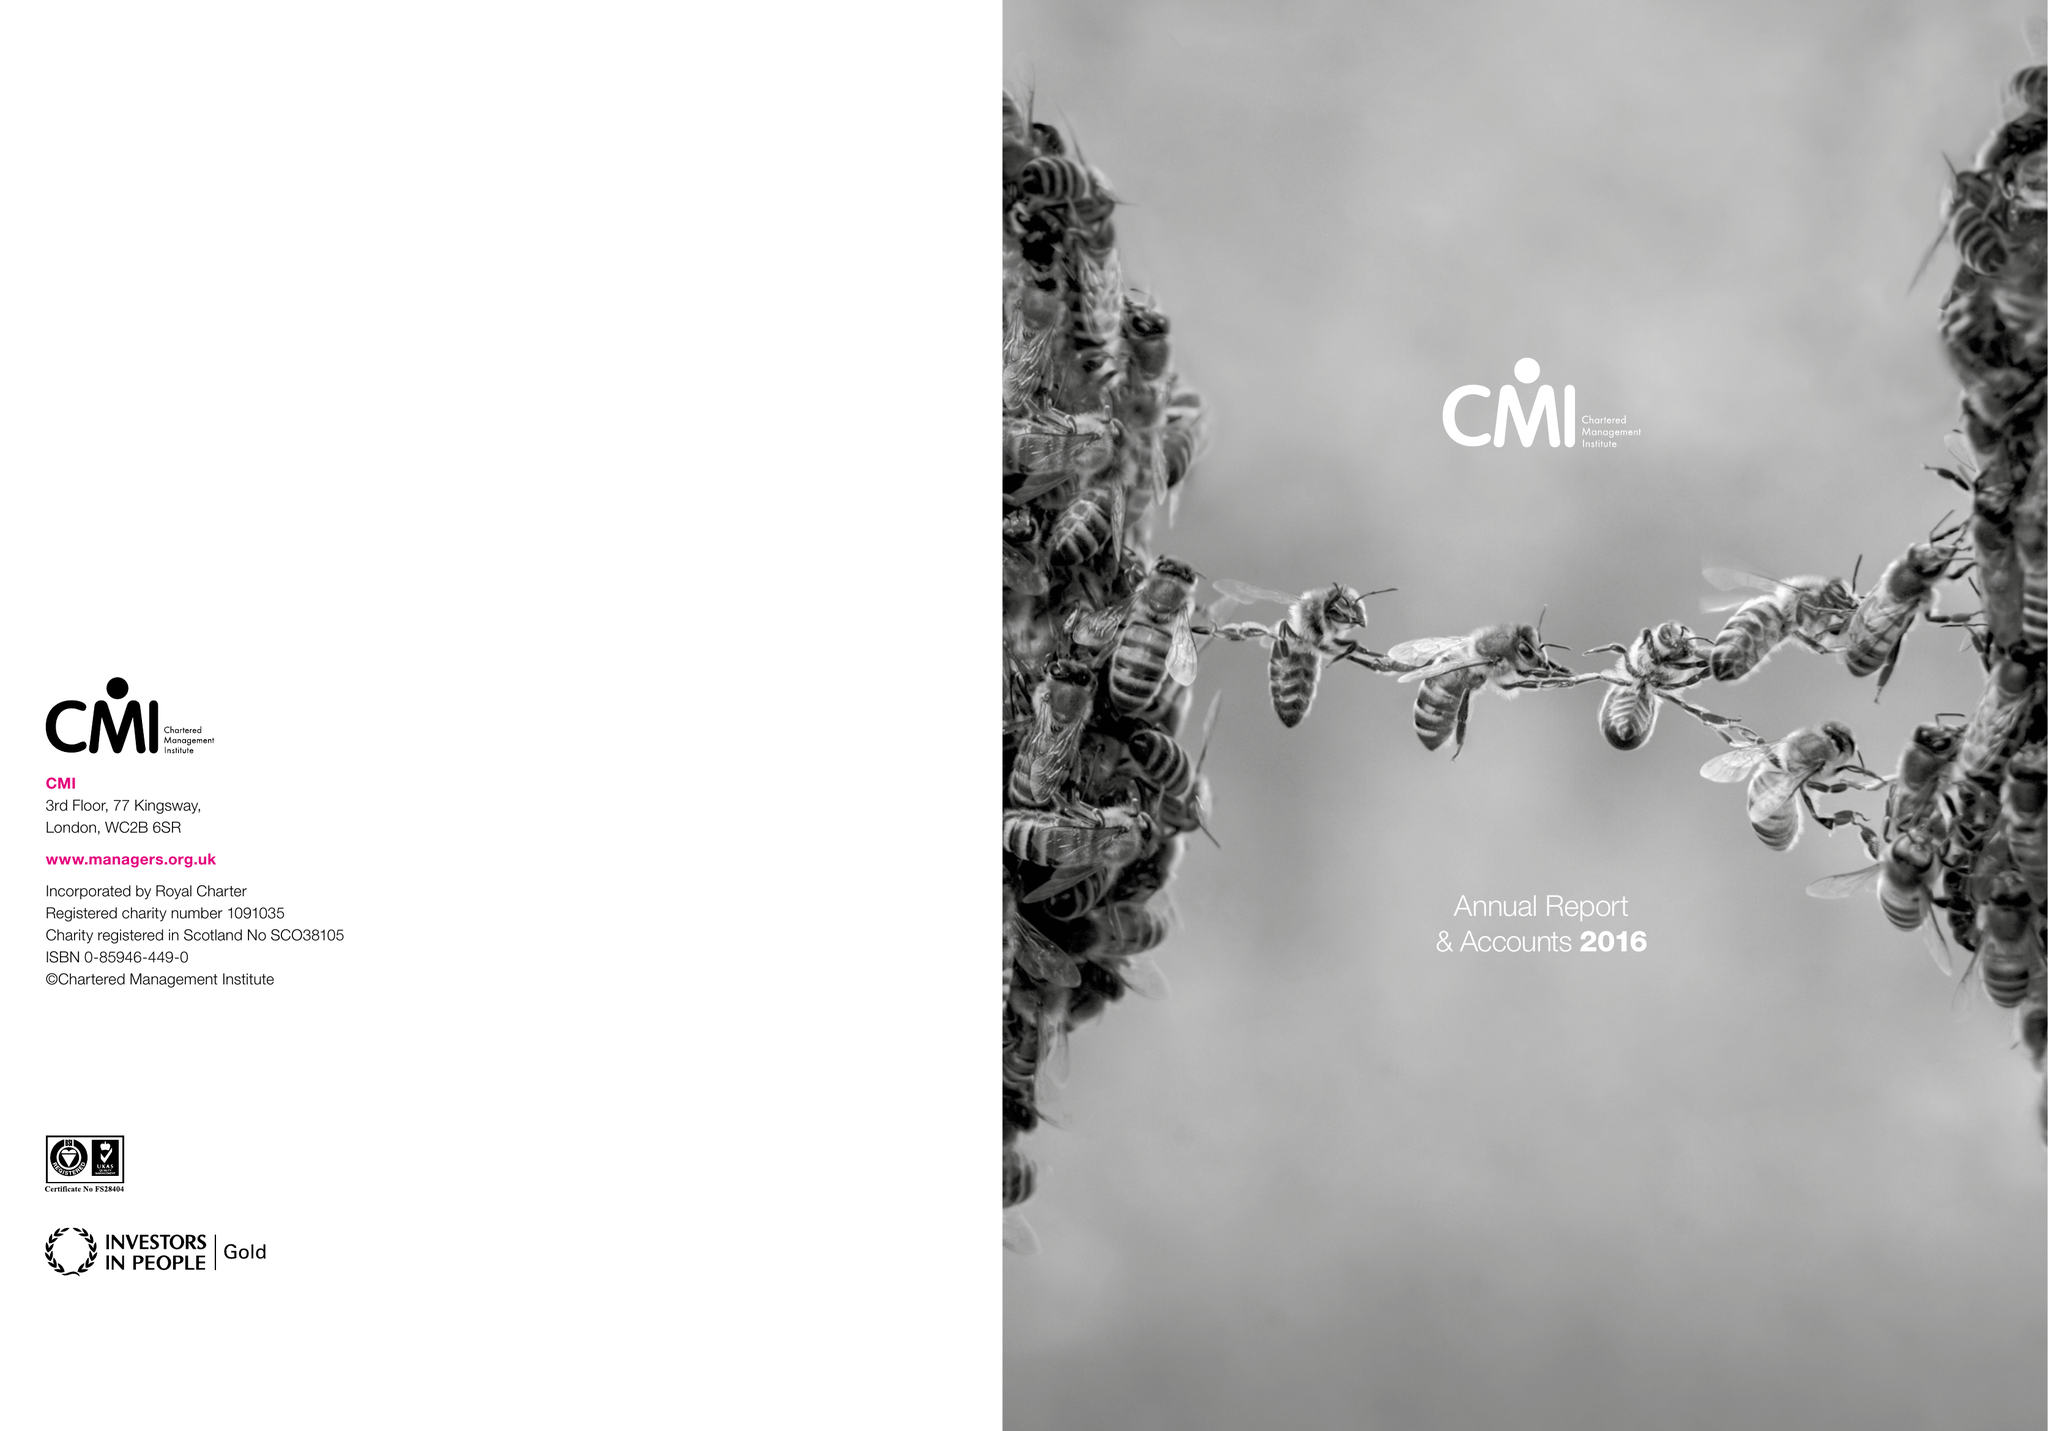What is the value for the income_annually_in_british_pounds?
Answer the question using a single word or phrase. 12725000.00 